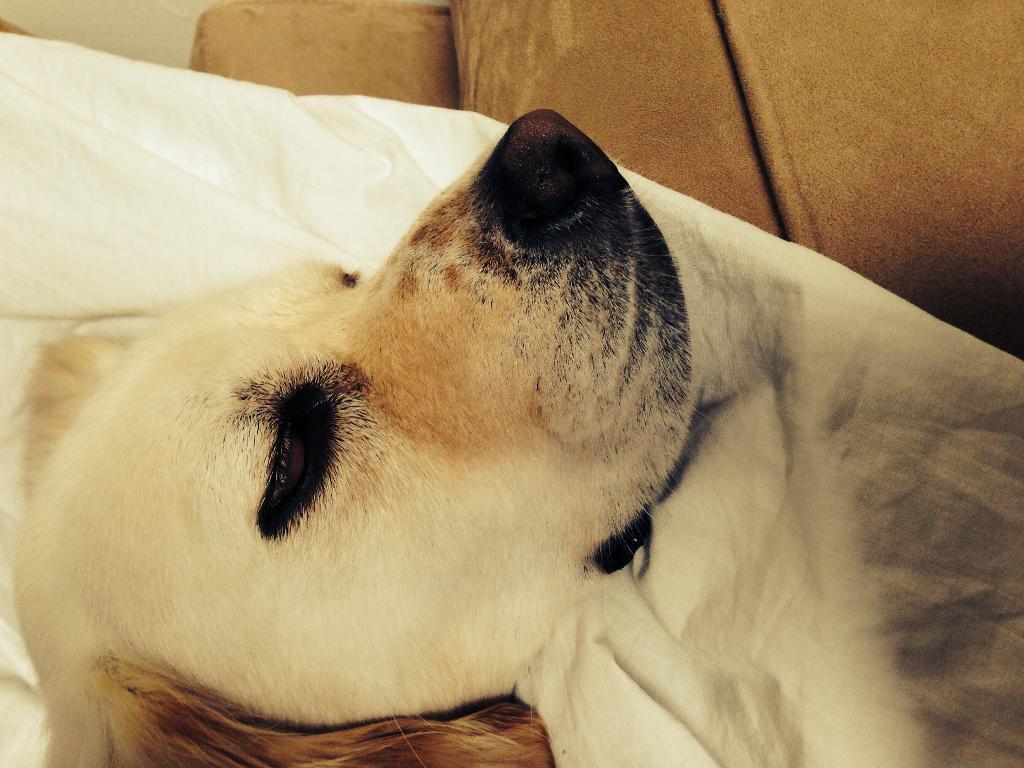Describe this image in one or two sentences. In this picture I can observe a dog. This dog is in cream color. In the background I can observe brown color sofa. 